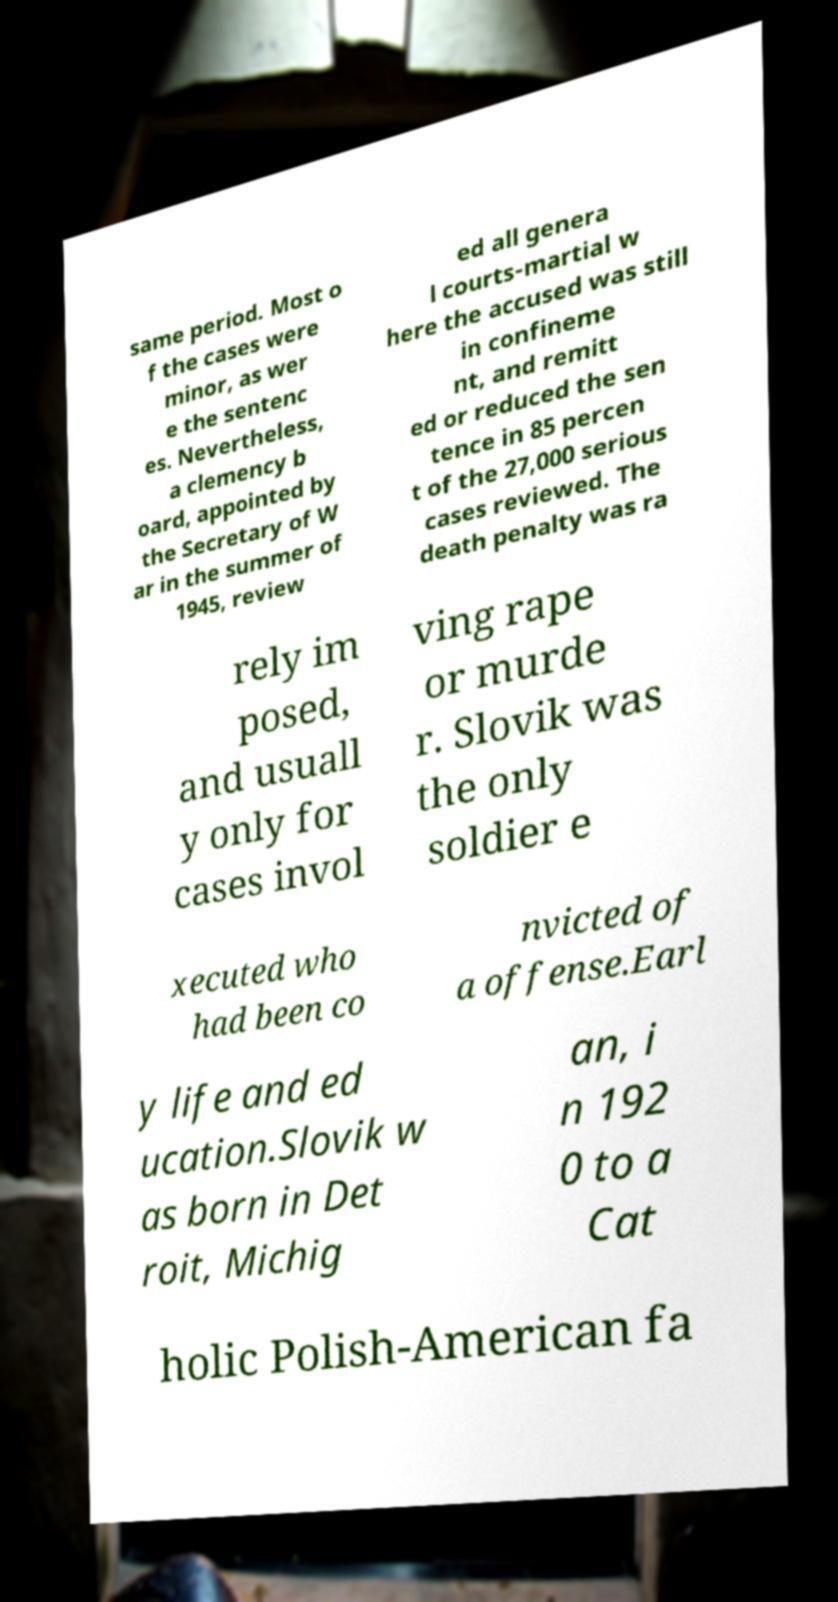There's text embedded in this image that I need extracted. Can you transcribe it verbatim? same period. Most o f the cases were minor, as wer e the sentenc es. Nevertheless, a clemency b oard, appointed by the Secretary of W ar in the summer of 1945, review ed all genera l courts-martial w here the accused was still in confineme nt, and remitt ed or reduced the sen tence in 85 percen t of the 27,000 serious cases reviewed. The death penalty was ra rely im posed, and usuall y only for cases invol ving rape or murde r. Slovik was the only soldier e xecuted who had been co nvicted of a offense.Earl y life and ed ucation.Slovik w as born in Det roit, Michig an, i n 192 0 to a Cat holic Polish-American fa 